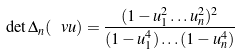<formula> <loc_0><loc_0><loc_500><loc_500>\det \Delta _ { n } ( \ v u ) = \frac { ( 1 - u _ { 1 } ^ { 2 } \dots u _ { n } ^ { 2 } ) ^ { 2 } } { ( 1 - u _ { 1 } ^ { 4 } ) \dots ( 1 - u _ { n } ^ { 4 } ) }</formula> 